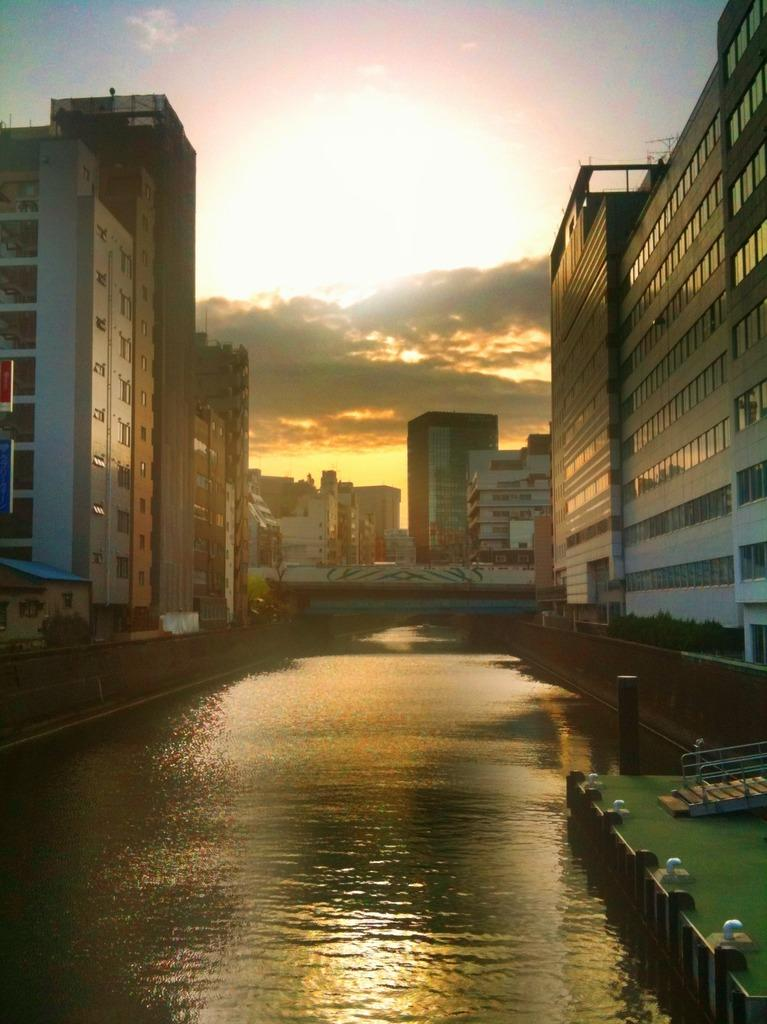What is the main feature in the middle of the picture? There is a lake in the middle of the picture. What else can be seen in the picture besides the lake? There are buildings in the picture. What is visible in the sky in the background of the image? There are clouds in the sky in the background of the image. Can you see a wren perched on the roof of one of the buildings in the image? There is no wren present in the image. 